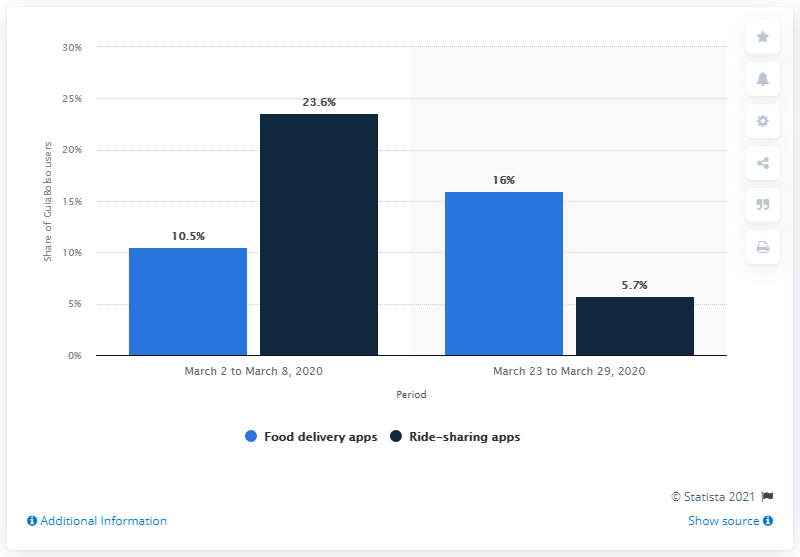Identify some key points in this picture. The average rating for food delivery apps is 13.25. The light blue represents the concept of food delivery apps. 